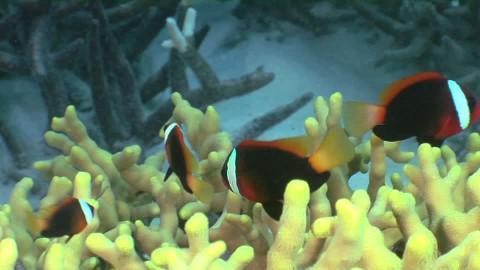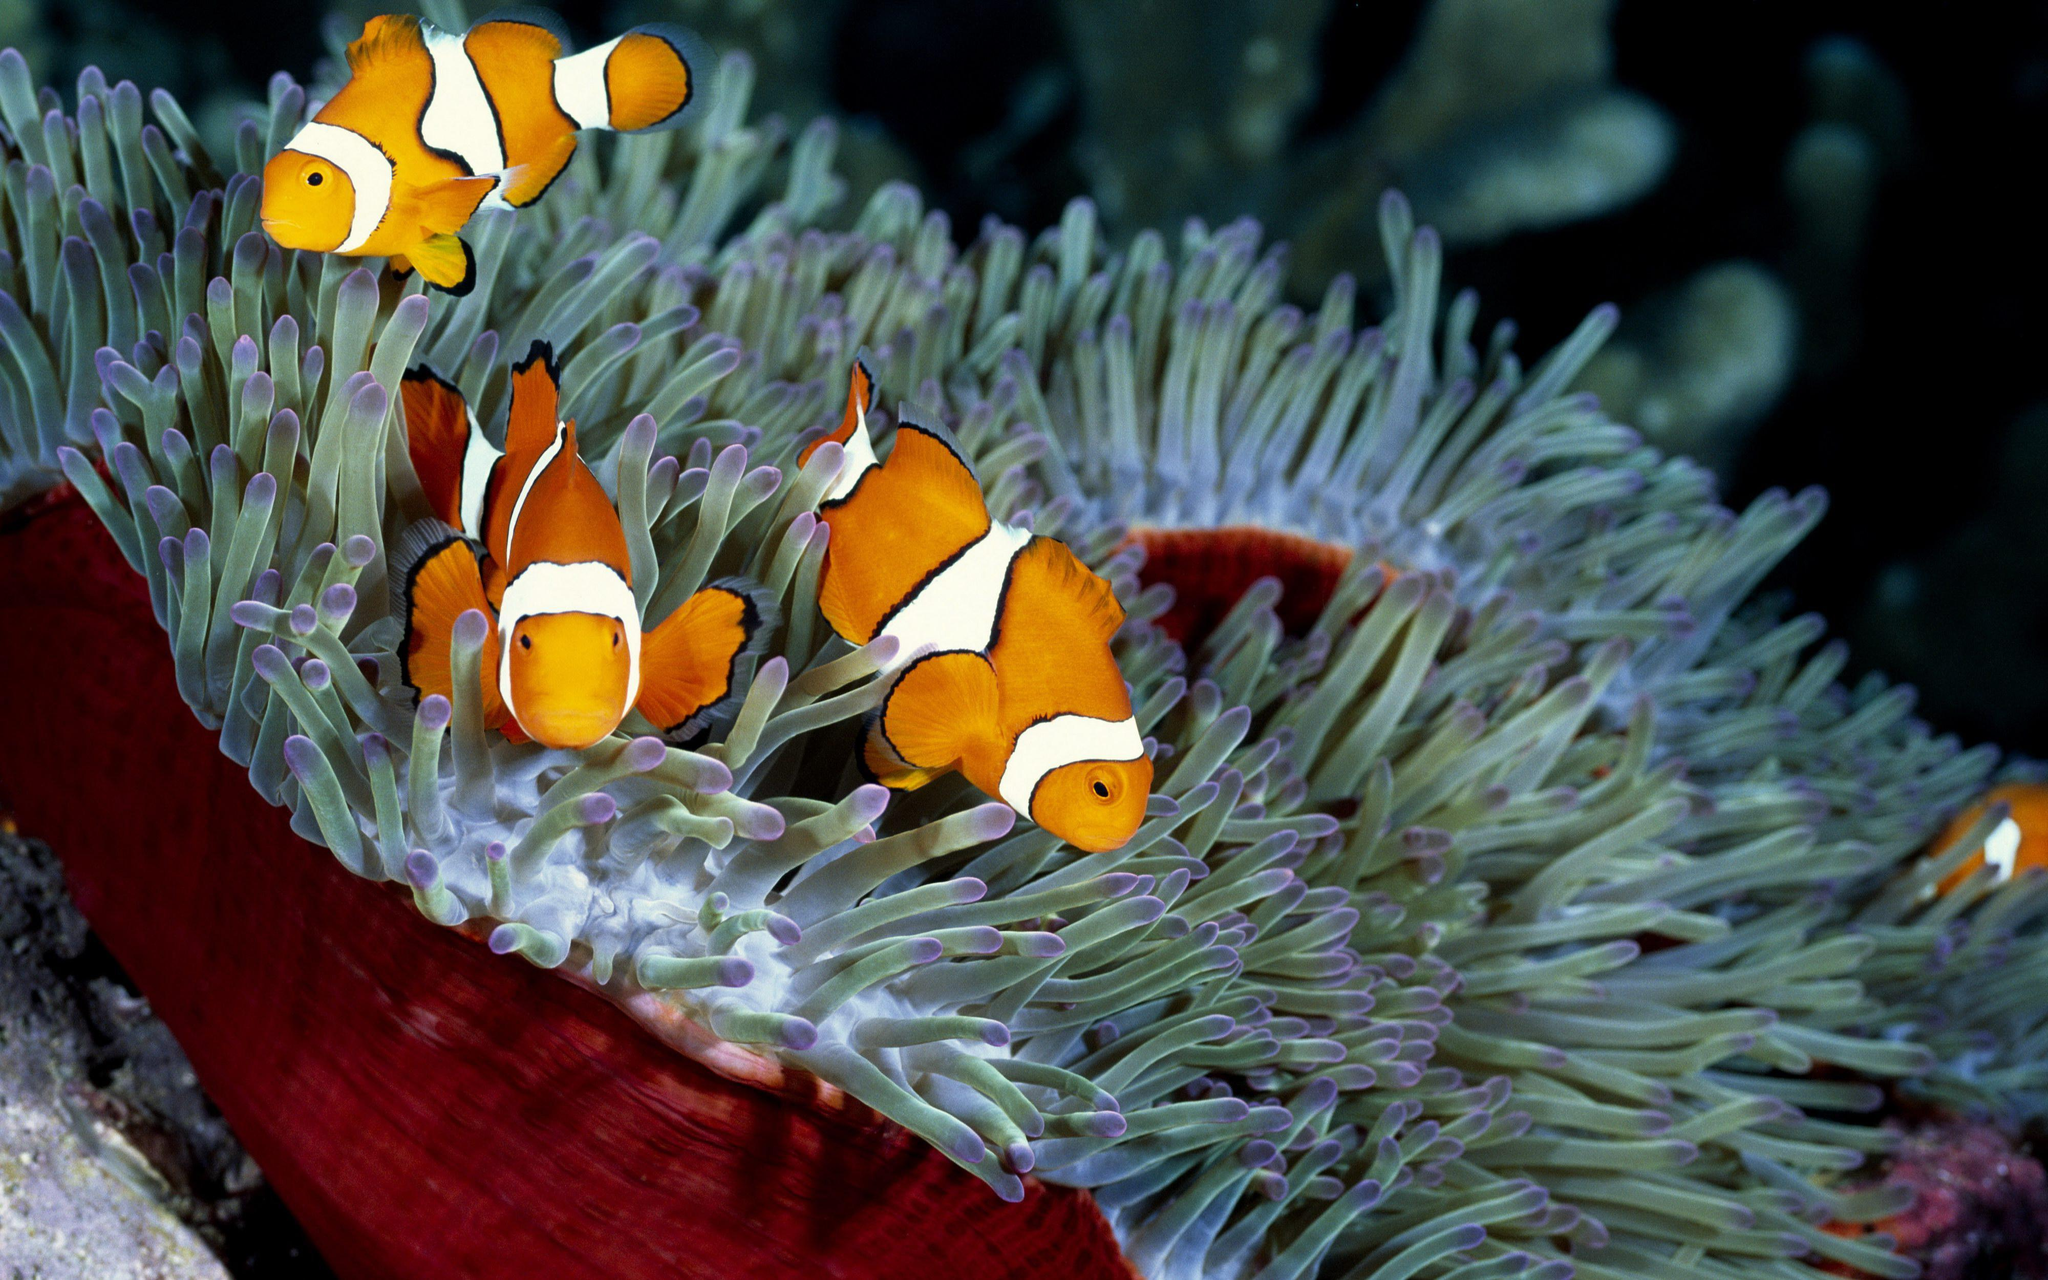The first image is the image on the left, the second image is the image on the right. Given the left and right images, does the statement "Each image shows multiple fish with white stripes swimming above anemone tendrils, and the left image features anemone tendrils with non-tapered yellow tips." hold true? Answer yes or no. Yes. The first image is the image on the left, the second image is the image on the right. For the images displayed, is the sentence "A single fish is swimming near the sea plant in the image on the left." factually correct? Answer yes or no. No. 